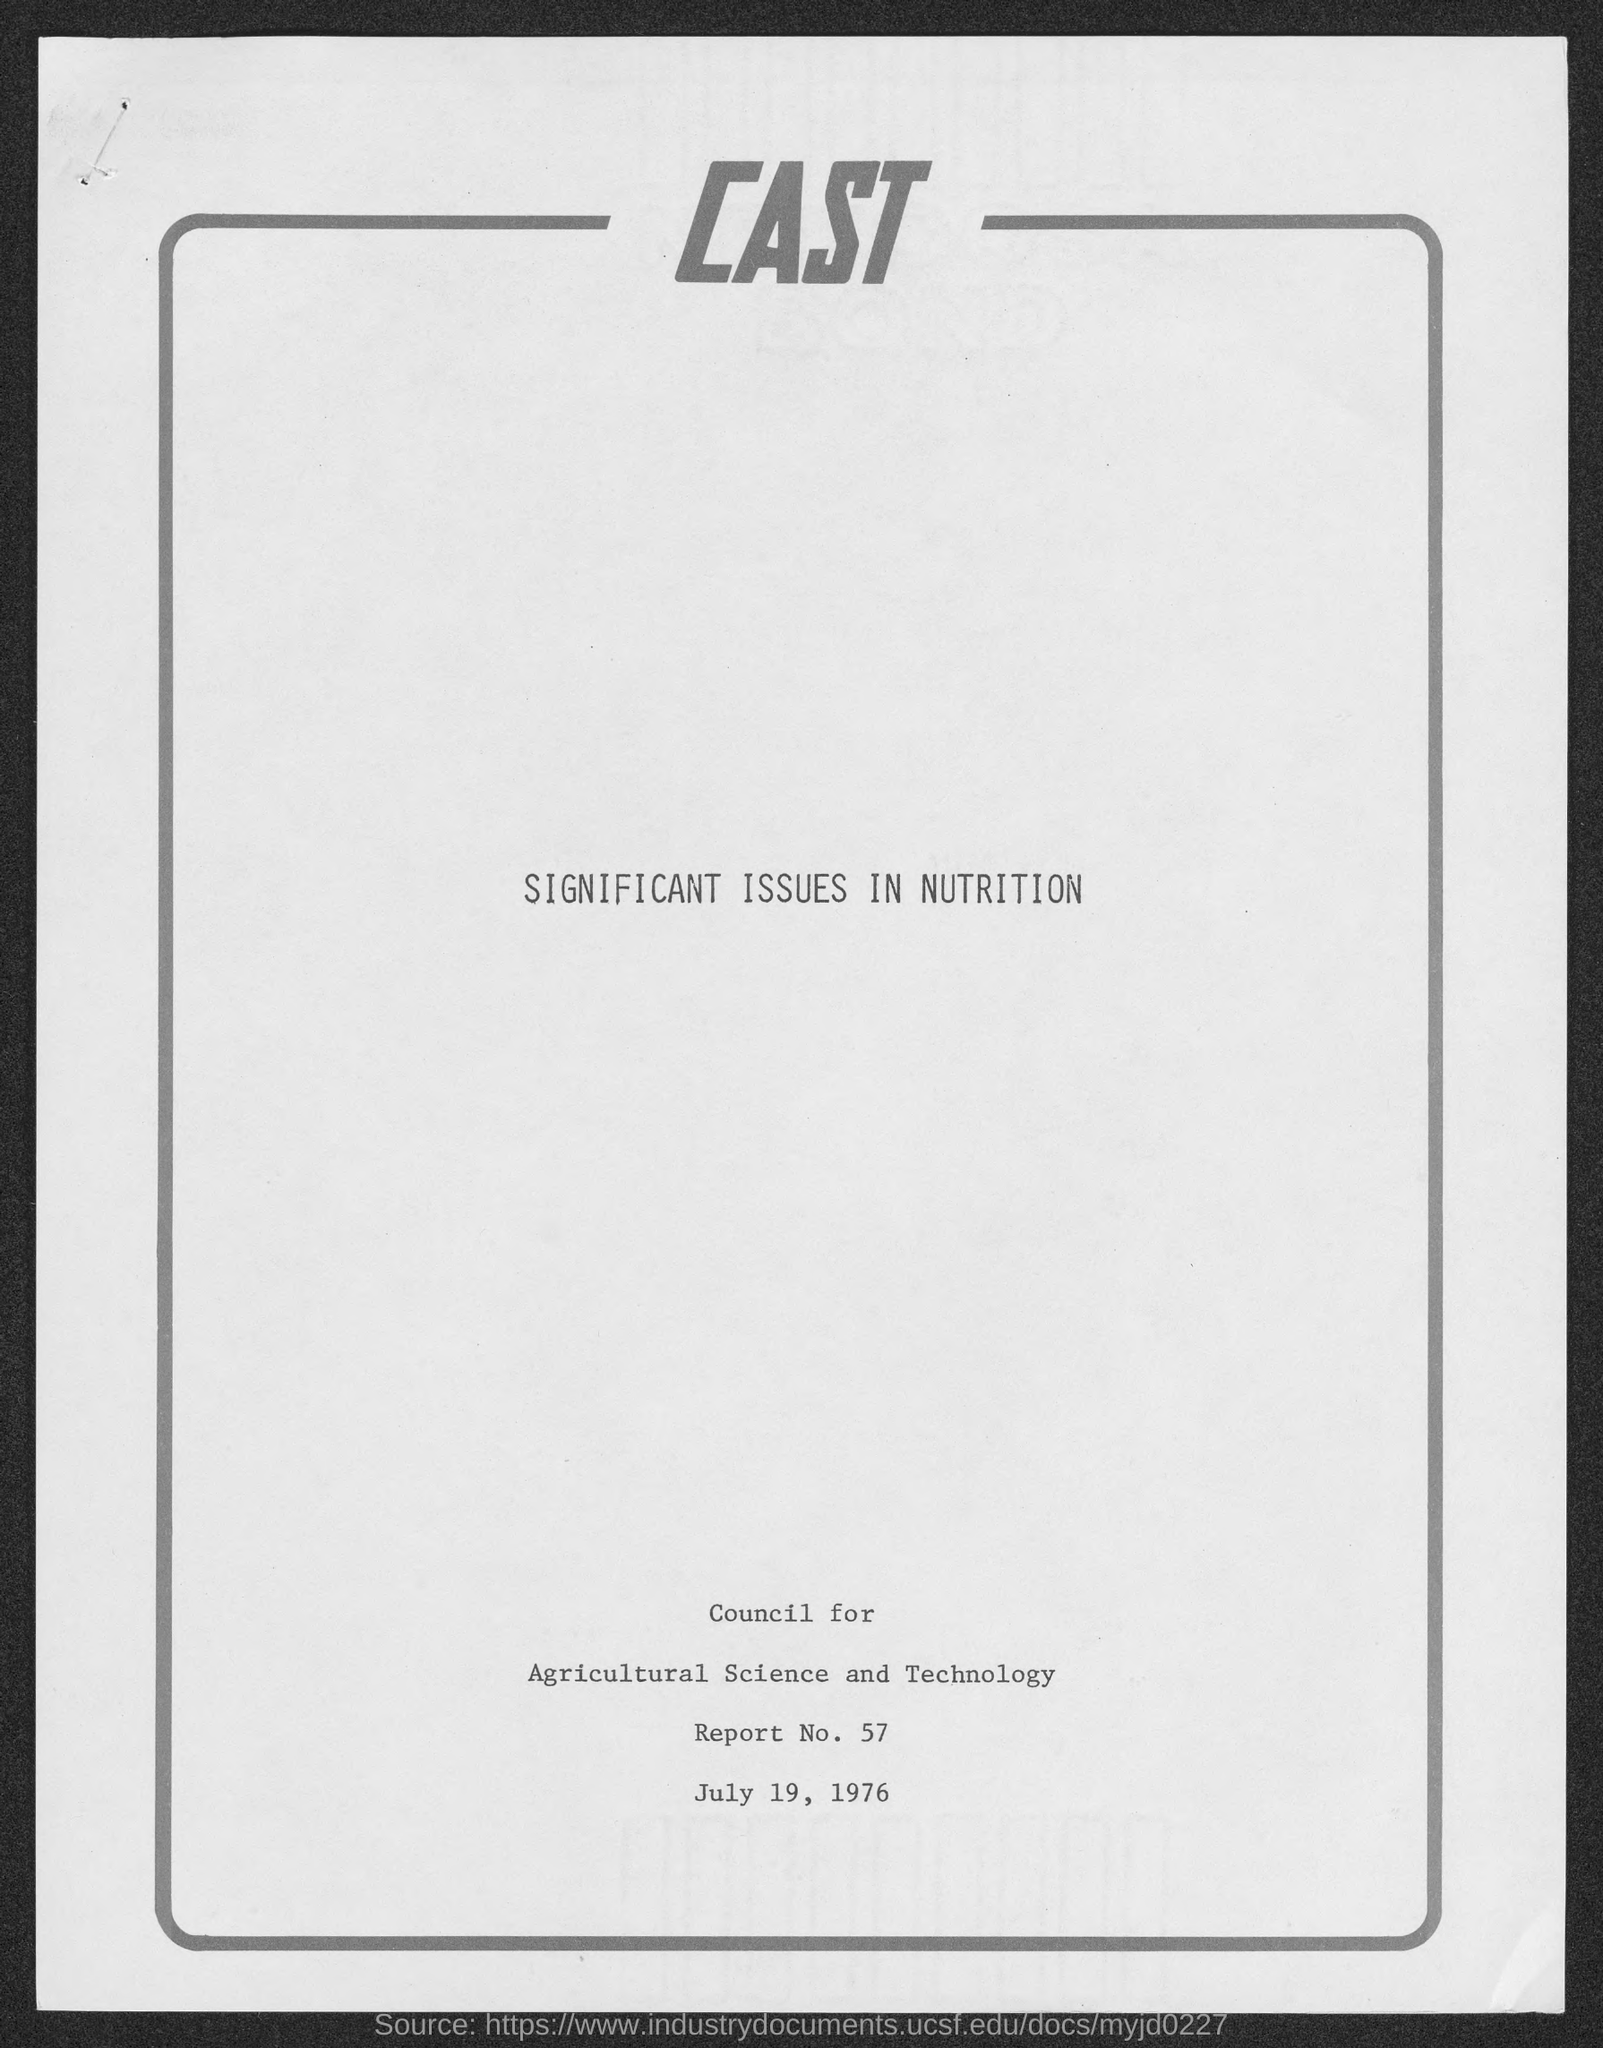Identify some key points in this picture. The Memorandum was dated July 19, 1976. The Report Number is Report No. 57. 